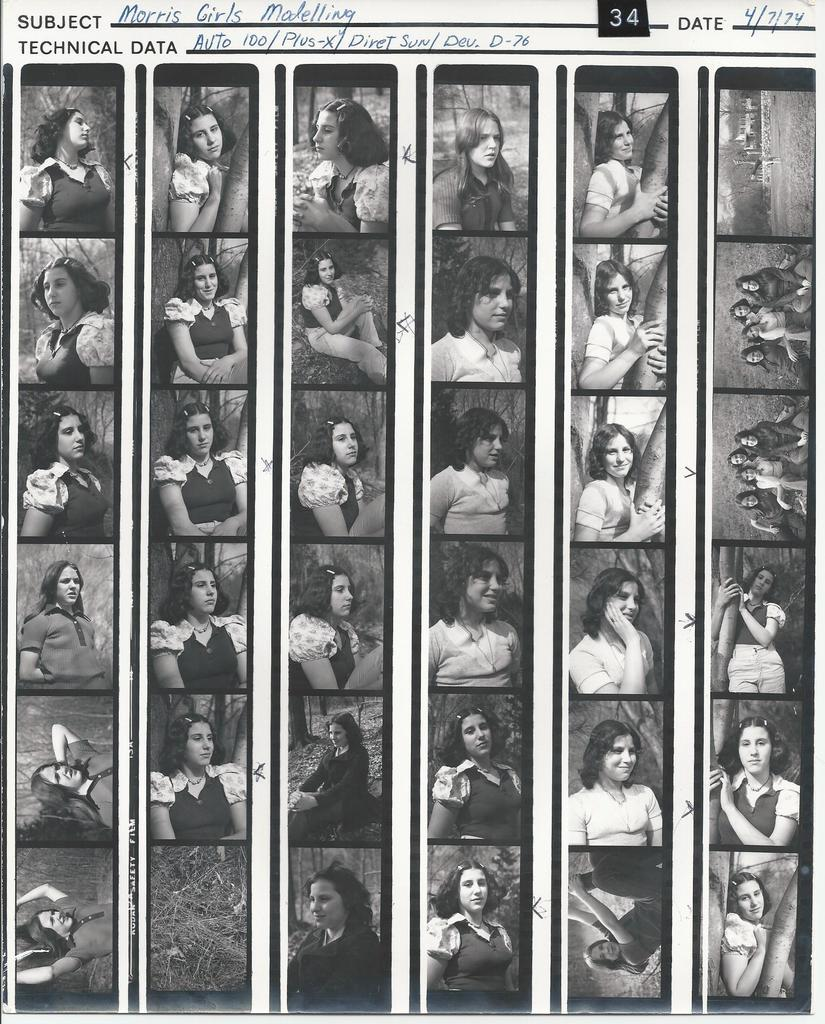What is the main object in the image? There is a paper in the image. What type of content is on the paper? The paper contains images of women. Is there any text on the paper? Yes, there is text on the paper. How does the sleet affect the control of the paper in the image? There is no sleet present in the image, so it cannot affect the control of the paper. 